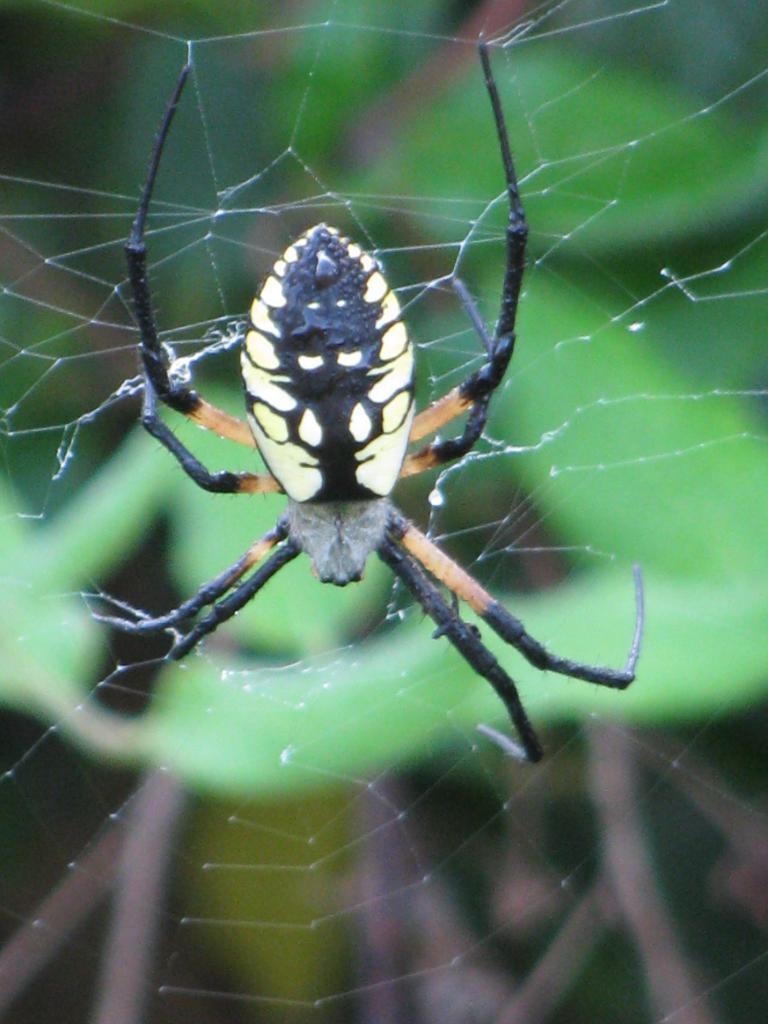Can you describe this image briefly? this picture shows a spider in the spider's web 